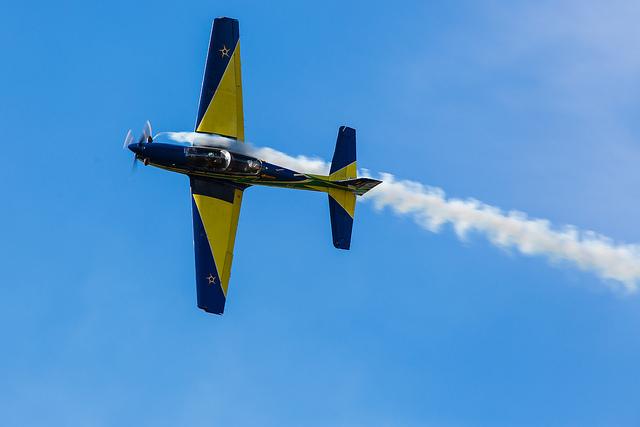What is the plain emitting?
Be succinct. Smoke. Which way is the plane angled?
Answer briefly. Sideways. What color is the plane?
Short answer required. Yellow and blue. What color is the plane's tail?
Concise answer only. Blue. 